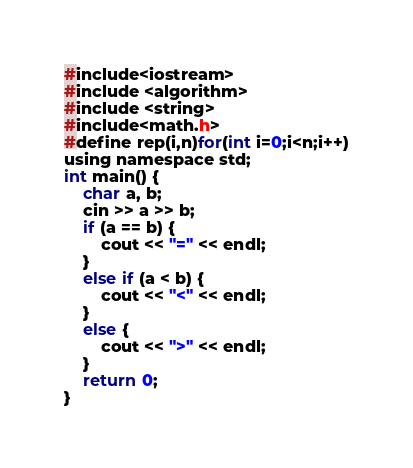<code> <loc_0><loc_0><loc_500><loc_500><_Java_>#include<iostream>
#include <algorithm>
#include <string>
#include<math.h>
#define rep(i,n)for(int i=0;i<n;i++)
using namespace std;
int main() {
    char a, b;
    cin >> a >> b;
    if (a == b) {
        cout << "=" << endl;
    }
    else if (a < b) {
        cout << "<" << endl;
    }
    else {
        cout << ">" << endl;
    }
    return 0;
}</code> 